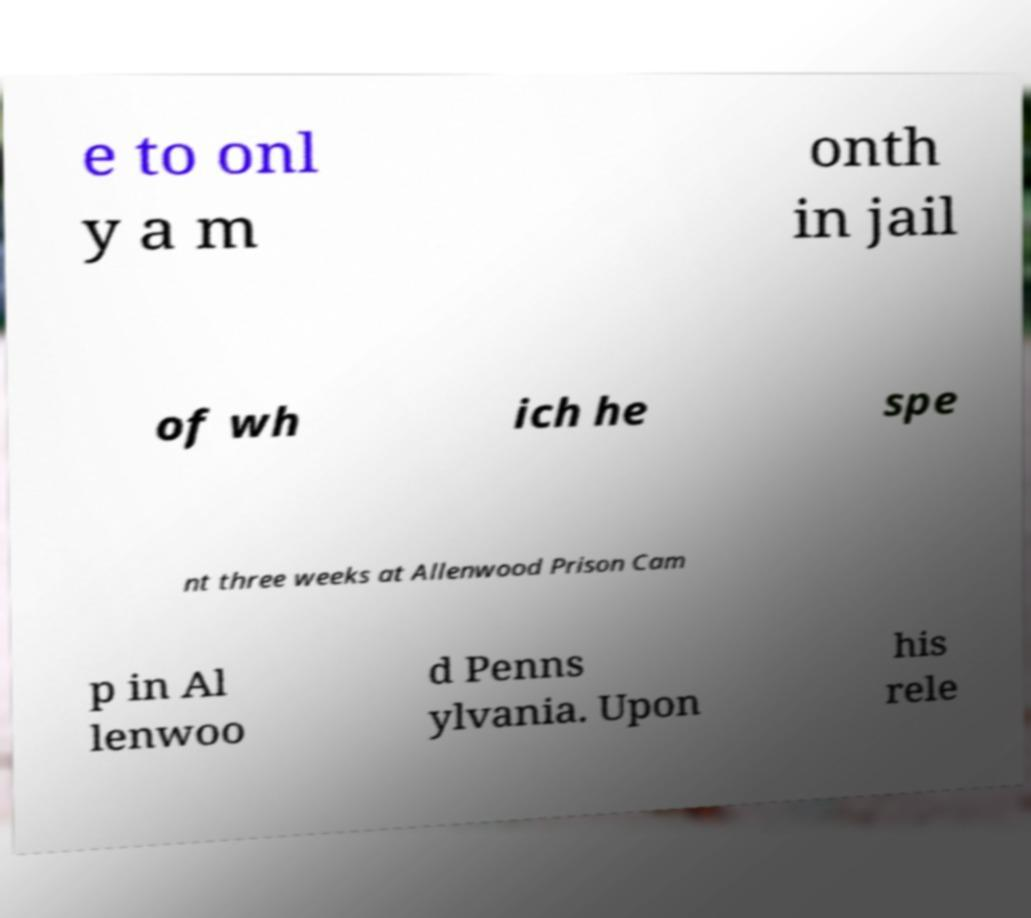Please identify and transcribe the text found in this image. e to onl y a m onth in jail of wh ich he spe nt three weeks at Allenwood Prison Cam p in Al lenwoo d Penns ylvania. Upon his rele 